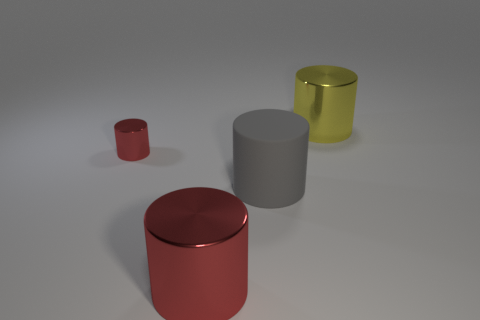Add 1 big gray matte blocks. How many objects exist? 5 Add 2 large red things. How many large red things exist? 3 Subtract 0 green balls. How many objects are left? 4 Subtract all large metal cylinders. Subtract all brown rubber spheres. How many objects are left? 2 Add 2 large yellow metallic things. How many large yellow metallic things are left? 3 